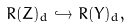Convert formula to latex. <formula><loc_0><loc_0><loc_500><loc_500>R ( Z ) _ { d } \hookrightarrow R ( Y ) _ { d } ,</formula> 